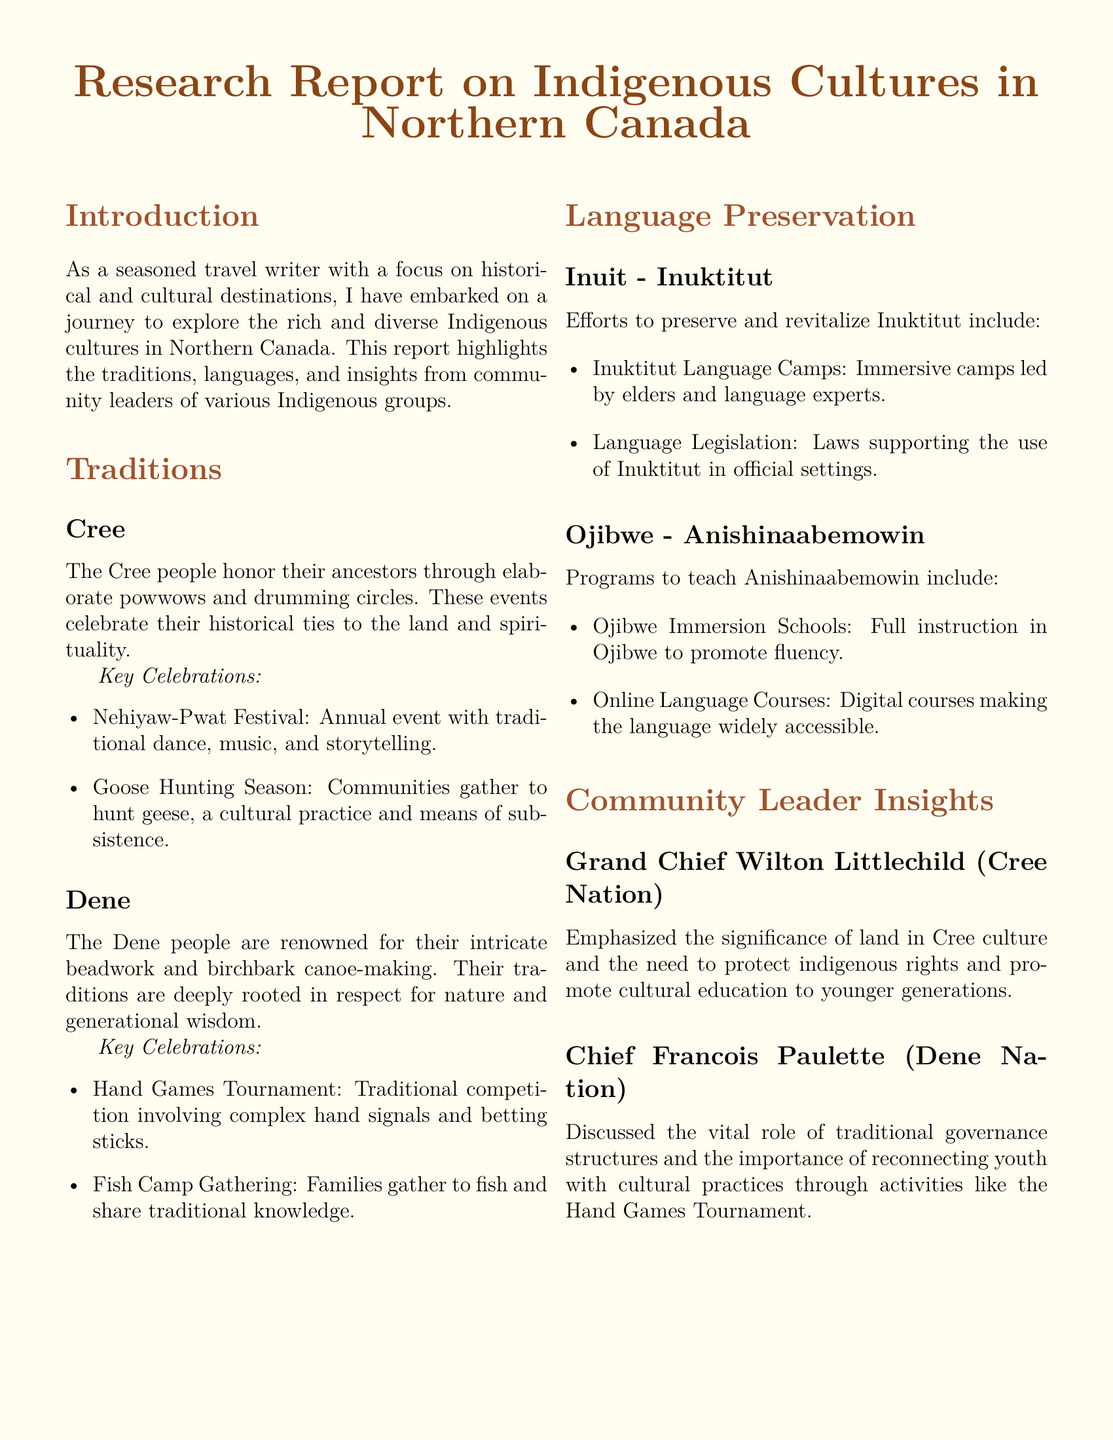What is the title of the report? The title of the report is prominently displayed at the top of the document.
Answer: Research Report on Indigenous Cultures in Northern Canada Who is the Grand Chief mentioned in the report? The document includes insights from a community leader specifically named at the start of his section.
Answer: Grand Chief Wilton Littlechild What is the annual festival celebrated by the Cree people? The document lists key celebrations for the Cree, one of which is mentioned first in the subsection.
Answer: Nehiyaw-Pwat Festival What language is being preserved through Inuktitut Language Camps? This information is found in the section dedicated to language preservation, specifically focusing on one Indigenous group.
Answer: Inuktitut What traditional activity do Dene families partake in during the Fish Camp Gathering? The document notes cultural practices and gatherings for the Dene people, highlighting a specific activity associated with fishing.
Answer: Fishing What kind of schools promote fluency in Anishinaabemowin? The report provides details on programs that teach a specific Indigenous language, including an important type of school mentioned in the section.
Answer: Ojibwe Immersion Schools What is a key feature of the Hand Games Tournament among the Dene? This question refers to the traditional competition described in the document, with details provided under the Dene section.
Answer: Traditional competition Which two languages are mentioned in the report? The document outlines efforts to preserve and teach specific languages, naming them in the respective subsections.
Answer: Inuktitut and Anishinaabemowin What role does land play in Cree culture according to the insights shared? The document describes Grand Chief Wilton Littlechild's emphasis on a particular aspect of Cree culture related to the land.
Answer: Significance 